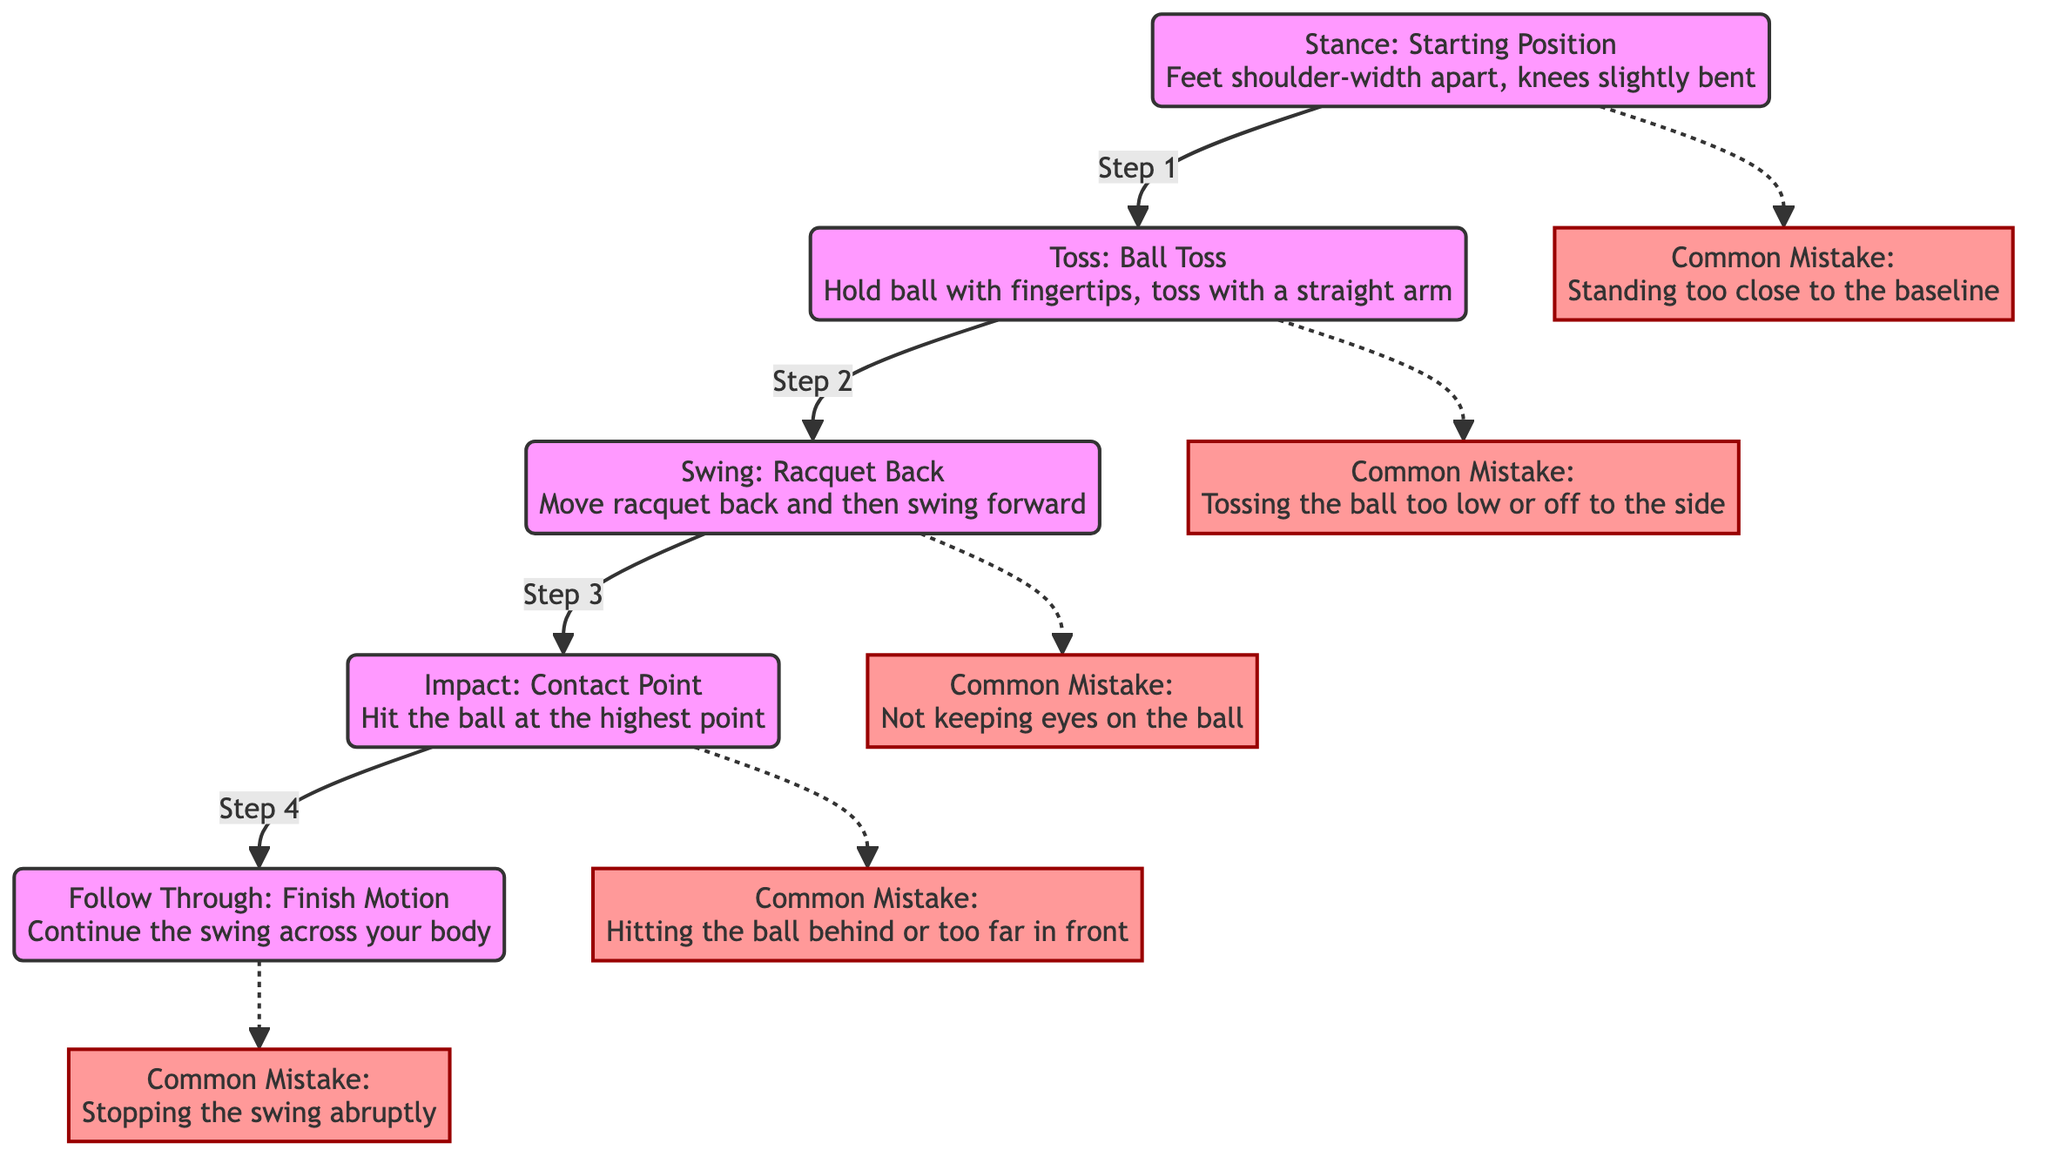What is the first phase of a tennis serve according to the diagram? The diagram outlines the phases of a tennis serve in a sequential order. The first phase listed is "Stance: Starting Position." Thus, the answer is derived directly from the topmost node in the flow.
Answer: Stance: Starting Position How many common mistakes are associated with the "Toss" phase? Reviewing the diagram, the "Toss" phase is linked to one specific common mistake: "Tossing the ball too low or off to the side." Therefore, the answer comes from identifying the connections to the mistakes from the toss phase.
Answer: 1 What are the steps in the serve sequence from stance to follow-through? The diagram illustrates a clear sequential flow from "Stance" to "Toss," then to "Swing," followed by "Impact," and finishing with "Follow Through." By following the arrows in the diagram, we can trace this four-step process.
Answer: Stance, Toss, Swing, Impact, Follow Through Which phase has a common mistake associated with stopping the swing abruptly? According to the diagram, the "Follow Through" phase is linked to the common mistake of "Stopping the swing abruptly." This mistake is indicated by the dashed arrow pointing from the follow-through phase to the mistake box.
Answer: Follow Through What is the common mistake related to the "Impact" phase of the serve? Looking at the diagram, the "Impact" phase is connected to the common mistake: "Hitting the ball behind or too far in front." This connection is explicit from the flowchart's structure, linking the impact phase directly to its associated mistake.
Answer: Hitting the ball behind or too far in front Which phase involves holding the ball with fingertips? The description for the "Toss" phase includes holding the ball with fingertips and tossing it with a straight arm. Thus, pinpointing the specific action described in this phase leads to the answer.
Answer: Toss What is the final action in the sequence of a tennis serve? The final action described in the progression is the "Follow Through: Finish Motion." By following the arrows from stance to follow-through, we see that this is the last phase in the sequence of a tennis serve.
Answer: Follow Through Why is it important to keep your eyes on the ball during the serve? The diagram notes a common mistake in the "Swing" phase as "Not keeping eyes on the ball." This reflects the importance of maintaining focus on the ball to execute a successful swing, indicating that it's a crucial aspect to avoid mistakes during this phase.
Answer: Not keeping eyes on the ball 